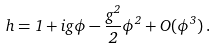Convert formula to latex. <formula><loc_0><loc_0><loc_500><loc_500>h = 1 + i g \phi - \frac { g ^ { 2 } } { 2 } \phi ^ { 2 } + O ( \phi ^ { 3 } ) \, .</formula> 